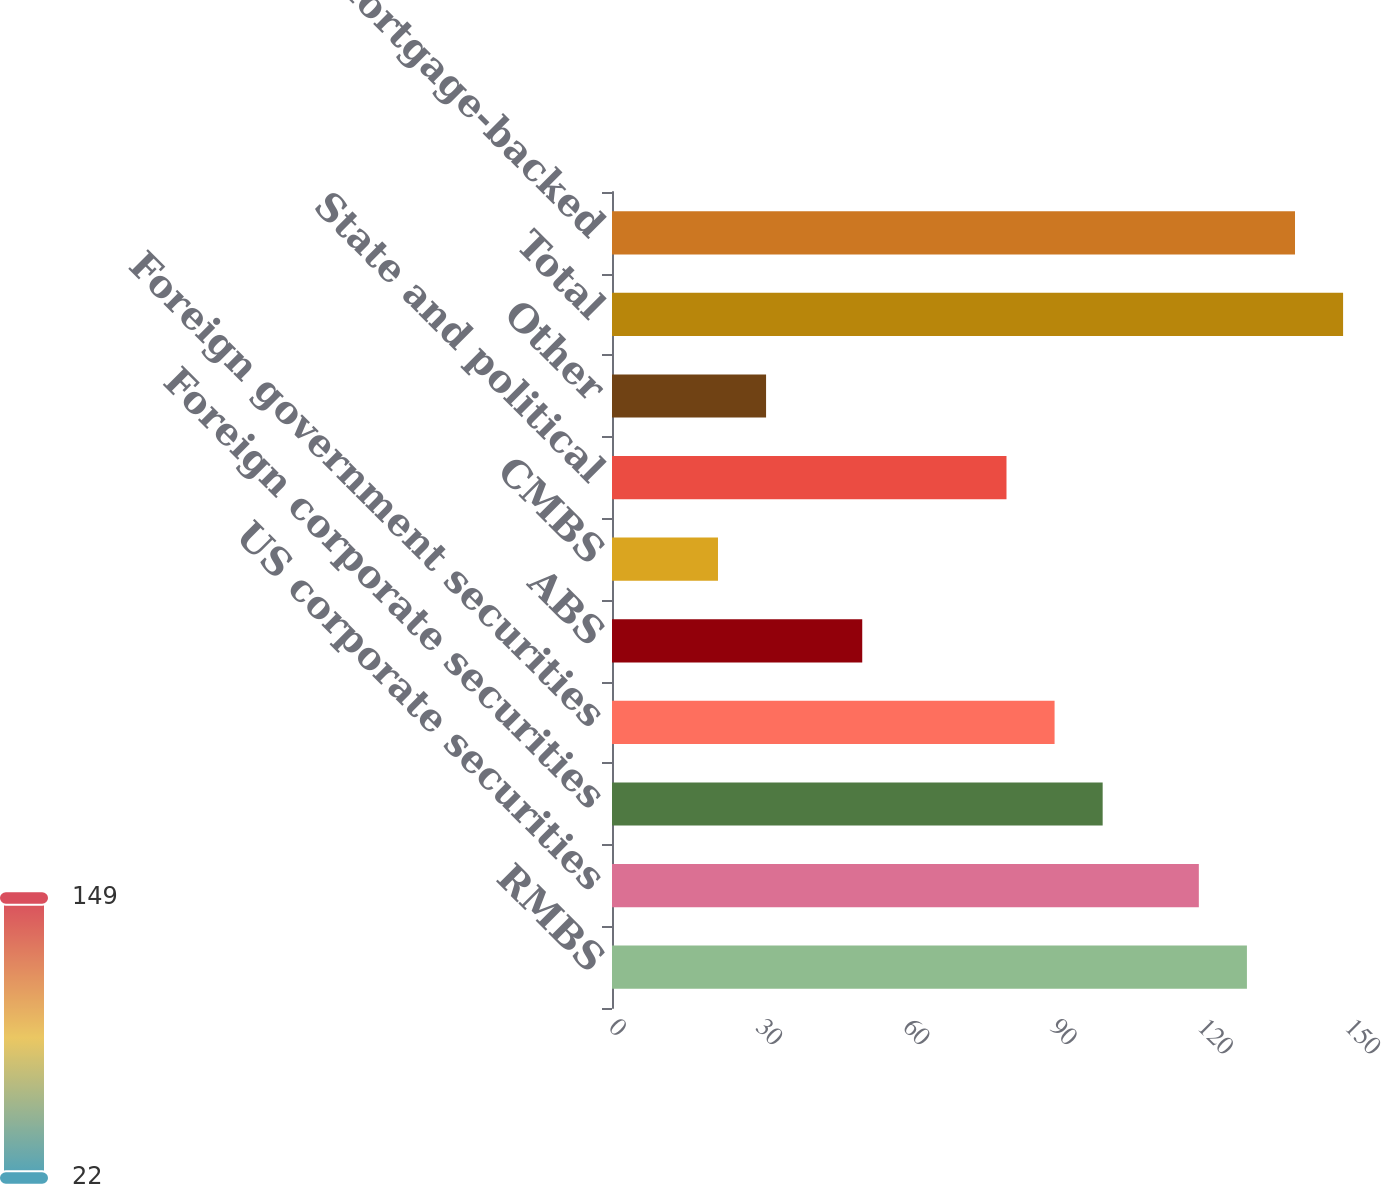Convert chart. <chart><loc_0><loc_0><loc_500><loc_500><bar_chart><fcel>RMBS<fcel>US corporate securities<fcel>Foreign corporate securities<fcel>Foreign government securities<fcel>ABS<fcel>CMBS<fcel>State and political<fcel>Other<fcel>Total<fcel>Mortgage-backed<nl><fcel>129.4<fcel>119.6<fcel>100<fcel>90.2<fcel>51<fcel>21.6<fcel>80.4<fcel>31.4<fcel>149<fcel>139.2<nl></chart> 